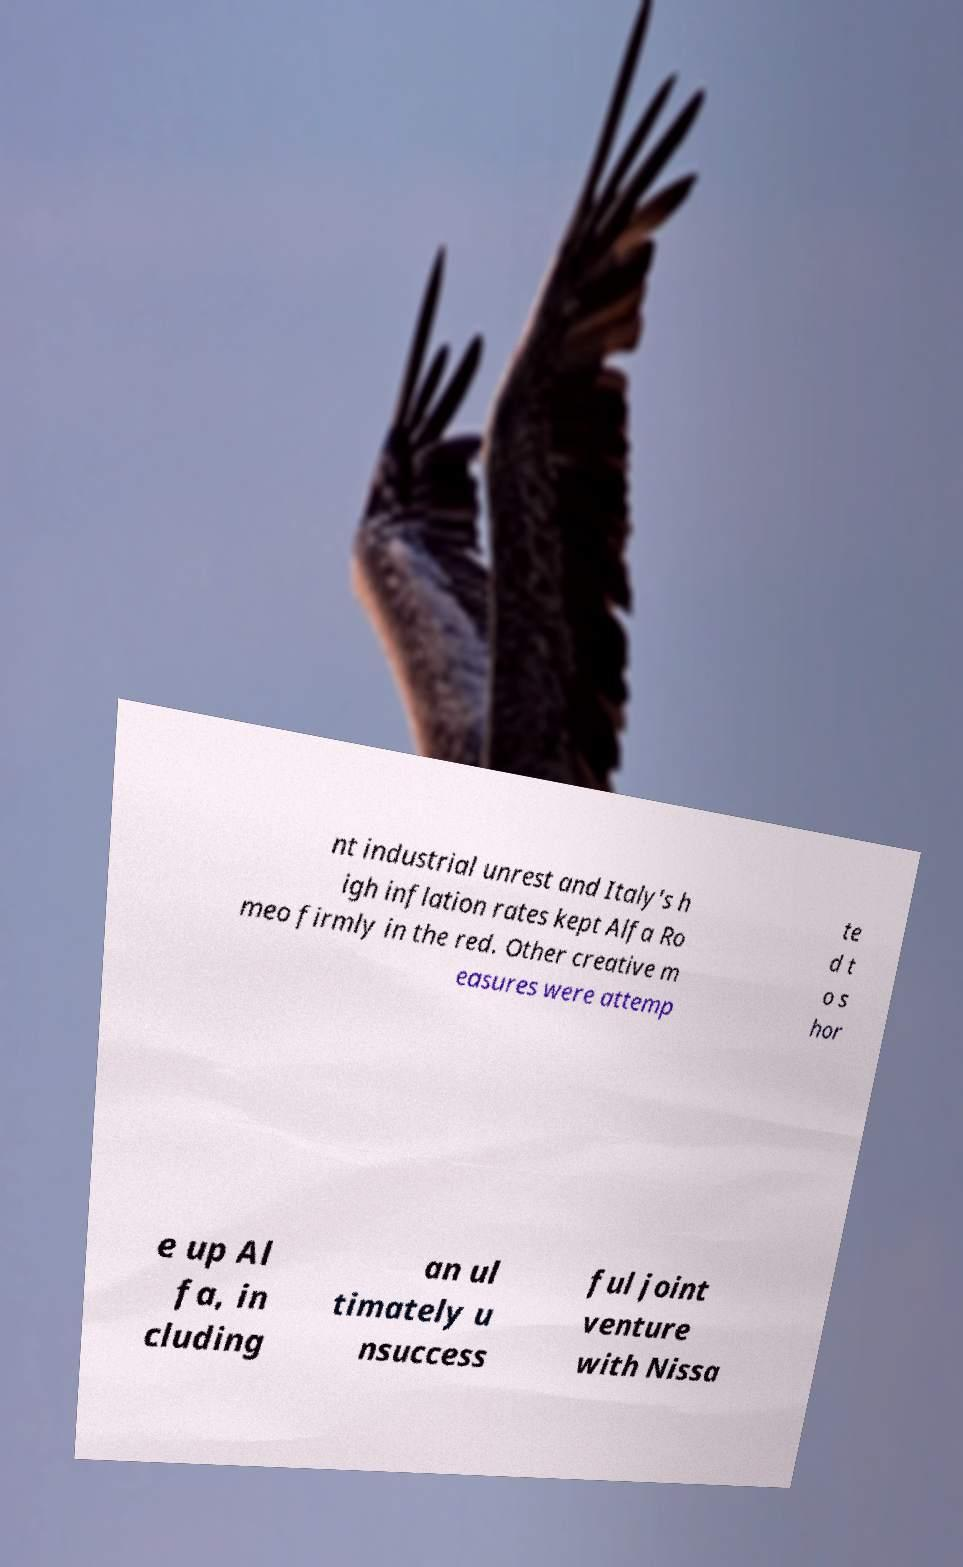There's text embedded in this image that I need extracted. Can you transcribe it verbatim? nt industrial unrest and Italy's h igh inflation rates kept Alfa Ro meo firmly in the red. Other creative m easures were attemp te d t o s hor e up Al fa, in cluding an ul timately u nsuccess ful joint venture with Nissa 